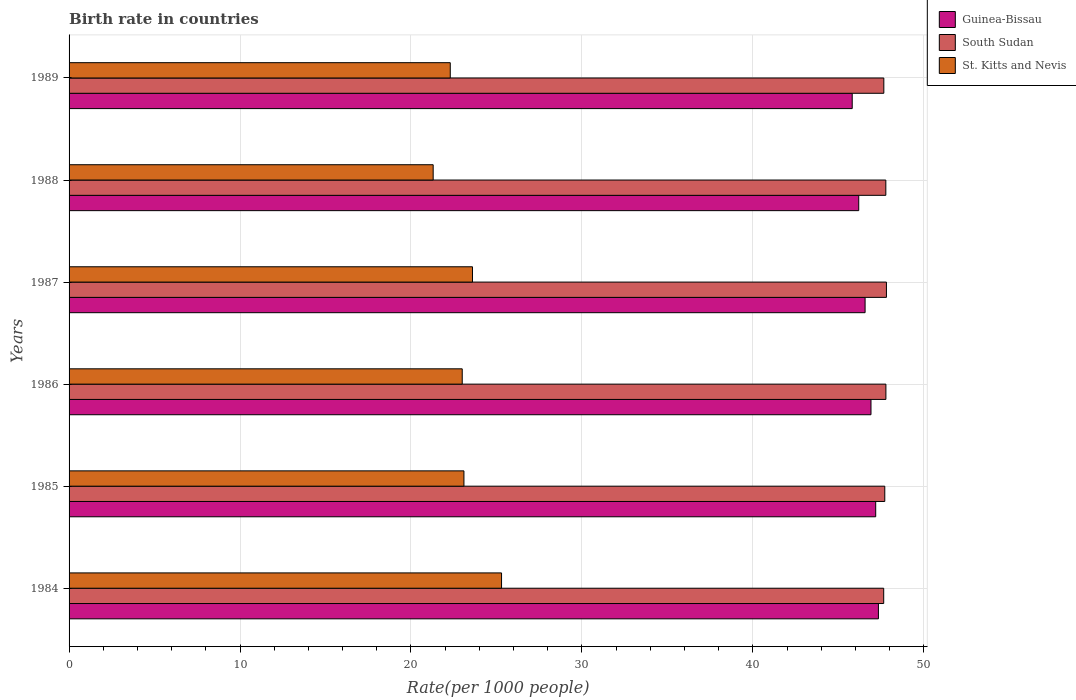How many different coloured bars are there?
Your answer should be compact. 3. How many bars are there on the 3rd tick from the top?
Your answer should be very brief. 3. What is the birth rate in St. Kitts and Nevis in 1988?
Offer a very short reply. 21.3. Across all years, what is the maximum birth rate in South Sudan?
Give a very brief answer. 47.82. Across all years, what is the minimum birth rate in South Sudan?
Offer a very short reply. 47.66. In which year was the birth rate in St. Kitts and Nevis maximum?
Keep it short and to the point. 1984. In which year was the birth rate in St. Kitts and Nevis minimum?
Ensure brevity in your answer.  1988. What is the total birth rate in St. Kitts and Nevis in the graph?
Offer a very short reply. 138.6. What is the difference between the birth rate in St. Kitts and Nevis in 1986 and that in 1989?
Keep it short and to the point. 0.7. What is the difference between the birth rate in Guinea-Bissau in 1987 and the birth rate in South Sudan in 1984?
Keep it short and to the point. -1.09. What is the average birth rate in St. Kitts and Nevis per year?
Ensure brevity in your answer.  23.1. In the year 1989, what is the difference between the birth rate in St. Kitts and Nevis and birth rate in South Sudan?
Keep it short and to the point. -25.36. In how many years, is the birth rate in South Sudan greater than 4 ?
Keep it short and to the point. 6. What is the ratio of the birth rate in St. Kitts and Nevis in 1984 to that in 1987?
Ensure brevity in your answer.  1.07. Is the birth rate in Guinea-Bissau in 1985 less than that in 1986?
Make the answer very short. No. Is the difference between the birth rate in St. Kitts and Nevis in 1984 and 1987 greater than the difference between the birth rate in South Sudan in 1984 and 1987?
Your answer should be very brief. Yes. What is the difference between the highest and the second highest birth rate in South Sudan?
Provide a short and direct response. 0.03. What is the difference between the highest and the lowest birth rate in South Sudan?
Give a very brief answer. 0.16. What does the 1st bar from the top in 1987 represents?
Offer a very short reply. St. Kitts and Nevis. What does the 2nd bar from the bottom in 1984 represents?
Give a very brief answer. South Sudan. Is it the case that in every year, the sum of the birth rate in Guinea-Bissau and birth rate in South Sudan is greater than the birth rate in St. Kitts and Nevis?
Provide a short and direct response. Yes. How many years are there in the graph?
Your answer should be compact. 6. Does the graph contain any zero values?
Provide a succinct answer. No. Does the graph contain grids?
Make the answer very short. Yes. Where does the legend appear in the graph?
Your answer should be very brief. Top right. What is the title of the graph?
Offer a terse response. Birth rate in countries. What is the label or title of the X-axis?
Make the answer very short. Rate(per 1000 people). What is the Rate(per 1000 people) of Guinea-Bissau in 1984?
Your answer should be compact. 47.35. What is the Rate(per 1000 people) of South Sudan in 1984?
Offer a very short reply. 47.66. What is the Rate(per 1000 people) of St. Kitts and Nevis in 1984?
Offer a terse response. 25.3. What is the Rate(per 1000 people) in Guinea-Bissau in 1985?
Ensure brevity in your answer.  47.19. What is the Rate(per 1000 people) in South Sudan in 1985?
Offer a very short reply. 47.72. What is the Rate(per 1000 people) of St. Kitts and Nevis in 1985?
Your response must be concise. 23.1. What is the Rate(per 1000 people) of Guinea-Bissau in 1986?
Give a very brief answer. 46.91. What is the Rate(per 1000 people) of South Sudan in 1986?
Offer a very short reply. 47.78. What is the Rate(per 1000 people) of St. Kitts and Nevis in 1986?
Your response must be concise. 23. What is the Rate(per 1000 people) of Guinea-Bissau in 1987?
Give a very brief answer. 46.57. What is the Rate(per 1000 people) of South Sudan in 1987?
Your answer should be very brief. 47.82. What is the Rate(per 1000 people) of St. Kitts and Nevis in 1987?
Give a very brief answer. 23.6. What is the Rate(per 1000 people) in Guinea-Bissau in 1988?
Provide a short and direct response. 46.2. What is the Rate(per 1000 people) of South Sudan in 1988?
Your answer should be compact. 47.78. What is the Rate(per 1000 people) in St. Kitts and Nevis in 1988?
Your answer should be very brief. 21.3. What is the Rate(per 1000 people) of Guinea-Bissau in 1989?
Your answer should be compact. 45.81. What is the Rate(per 1000 people) in South Sudan in 1989?
Your response must be concise. 47.66. What is the Rate(per 1000 people) of St. Kitts and Nevis in 1989?
Provide a succinct answer. 22.3. Across all years, what is the maximum Rate(per 1000 people) in Guinea-Bissau?
Offer a very short reply. 47.35. Across all years, what is the maximum Rate(per 1000 people) in South Sudan?
Offer a terse response. 47.82. Across all years, what is the maximum Rate(per 1000 people) of St. Kitts and Nevis?
Offer a very short reply. 25.3. Across all years, what is the minimum Rate(per 1000 people) of Guinea-Bissau?
Your answer should be very brief. 45.81. Across all years, what is the minimum Rate(per 1000 people) of South Sudan?
Provide a succinct answer. 47.66. Across all years, what is the minimum Rate(per 1000 people) of St. Kitts and Nevis?
Provide a short and direct response. 21.3. What is the total Rate(per 1000 people) in Guinea-Bissau in the graph?
Keep it short and to the point. 280.02. What is the total Rate(per 1000 people) of South Sudan in the graph?
Your answer should be compact. 286.42. What is the total Rate(per 1000 people) of St. Kitts and Nevis in the graph?
Your response must be concise. 138.6. What is the difference between the Rate(per 1000 people) of Guinea-Bissau in 1984 and that in 1985?
Provide a succinct answer. 0.16. What is the difference between the Rate(per 1000 people) of South Sudan in 1984 and that in 1985?
Make the answer very short. -0.06. What is the difference between the Rate(per 1000 people) of St. Kitts and Nevis in 1984 and that in 1985?
Make the answer very short. 2.2. What is the difference between the Rate(per 1000 people) in Guinea-Bissau in 1984 and that in 1986?
Your answer should be very brief. 0.43. What is the difference between the Rate(per 1000 people) of South Sudan in 1984 and that in 1986?
Ensure brevity in your answer.  -0.13. What is the difference between the Rate(per 1000 people) in Guinea-Bissau in 1984 and that in 1987?
Keep it short and to the point. 0.78. What is the difference between the Rate(per 1000 people) of South Sudan in 1984 and that in 1987?
Give a very brief answer. -0.16. What is the difference between the Rate(per 1000 people) of St. Kitts and Nevis in 1984 and that in 1987?
Make the answer very short. 1.7. What is the difference between the Rate(per 1000 people) in Guinea-Bissau in 1984 and that in 1988?
Give a very brief answer. 1.15. What is the difference between the Rate(per 1000 people) of South Sudan in 1984 and that in 1988?
Give a very brief answer. -0.12. What is the difference between the Rate(per 1000 people) of St. Kitts and Nevis in 1984 and that in 1988?
Your answer should be compact. 4. What is the difference between the Rate(per 1000 people) of Guinea-Bissau in 1984 and that in 1989?
Offer a terse response. 1.53. What is the difference between the Rate(per 1000 people) in South Sudan in 1984 and that in 1989?
Provide a short and direct response. -0.01. What is the difference between the Rate(per 1000 people) in Guinea-Bissau in 1985 and that in 1986?
Your answer should be very brief. 0.28. What is the difference between the Rate(per 1000 people) of South Sudan in 1985 and that in 1986?
Your response must be concise. -0.07. What is the difference between the Rate(per 1000 people) in Guinea-Bissau in 1985 and that in 1987?
Offer a very short reply. 0.62. What is the difference between the Rate(per 1000 people) in South Sudan in 1985 and that in 1987?
Provide a succinct answer. -0.1. What is the difference between the Rate(per 1000 people) in South Sudan in 1985 and that in 1988?
Offer a very short reply. -0.06. What is the difference between the Rate(per 1000 people) of Guinea-Bissau in 1985 and that in 1989?
Offer a terse response. 1.37. What is the difference between the Rate(per 1000 people) in South Sudan in 1985 and that in 1989?
Your response must be concise. 0.06. What is the difference between the Rate(per 1000 people) in St. Kitts and Nevis in 1985 and that in 1989?
Your response must be concise. 0.8. What is the difference between the Rate(per 1000 people) of Guinea-Bissau in 1986 and that in 1987?
Provide a succinct answer. 0.34. What is the difference between the Rate(per 1000 people) of South Sudan in 1986 and that in 1987?
Offer a very short reply. -0.03. What is the difference between the Rate(per 1000 people) of Guinea-Bissau in 1986 and that in 1988?
Your response must be concise. 0.72. What is the difference between the Rate(per 1000 people) in South Sudan in 1986 and that in 1988?
Keep it short and to the point. 0.01. What is the difference between the Rate(per 1000 people) in St. Kitts and Nevis in 1986 and that in 1988?
Your answer should be compact. 1.7. What is the difference between the Rate(per 1000 people) in Guinea-Bissau in 1986 and that in 1989?
Provide a succinct answer. 1.1. What is the difference between the Rate(per 1000 people) in South Sudan in 1986 and that in 1989?
Your answer should be very brief. 0.12. What is the difference between the Rate(per 1000 people) of Guinea-Bissau in 1987 and that in 1988?
Offer a very short reply. 0.37. What is the difference between the Rate(per 1000 people) of South Sudan in 1987 and that in 1988?
Make the answer very short. 0.04. What is the difference between the Rate(per 1000 people) in St. Kitts and Nevis in 1987 and that in 1988?
Give a very brief answer. 2.3. What is the difference between the Rate(per 1000 people) in Guinea-Bissau in 1987 and that in 1989?
Offer a very short reply. 0.75. What is the difference between the Rate(per 1000 people) in South Sudan in 1987 and that in 1989?
Offer a very short reply. 0.15. What is the difference between the Rate(per 1000 people) of Guinea-Bissau in 1988 and that in 1989?
Offer a terse response. 0.38. What is the difference between the Rate(per 1000 people) of South Sudan in 1988 and that in 1989?
Your response must be concise. 0.12. What is the difference between the Rate(per 1000 people) in St. Kitts and Nevis in 1988 and that in 1989?
Your answer should be very brief. -1. What is the difference between the Rate(per 1000 people) in Guinea-Bissau in 1984 and the Rate(per 1000 people) in South Sudan in 1985?
Your answer should be very brief. -0.37. What is the difference between the Rate(per 1000 people) in Guinea-Bissau in 1984 and the Rate(per 1000 people) in St. Kitts and Nevis in 1985?
Offer a terse response. 24.25. What is the difference between the Rate(per 1000 people) of South Sudan in 1984 and the Rate(per 1000 people) of St. Kitts and Nevis in 1985?
Offer a very short reply. 24.56. What is the difference between the Rate(per 1000 people) in Guinea-Bissau in 1984 and the Rate(per 1000 people) in South Sudan in 1986?
Ensure brevity in your answer.  -0.44. What is the difference between the Rate(per 1000 people) of Guinea-Bissau in 1984 and the Rate(per 1000 people) of St. Kitts and Nevis in 1986?
Your answer should be very brief. 24.35. What is the difference between the Rate(per 1000 people) in South Sudan in 1984 and the Rate(per 1000 people) in St. Kitts and Nevis in 1986?
Offer a very short reply. 24.66. What is the difference between the Rate(per 1000 people) of Guinea-Bissau in 1984 and the Rate(per 1000 people) of South Sudan in 1987?
Your answer should be compact. -0.47. What is the difference between the Rate(per 1000 people) in Guinea-Bissau in 1984 and the Rate(per 1000 people) in St. Kitts and Nevis in 1987?
Your response must be concise. 23.75. What is the difference between the Rate(per 1000 people) in South Sudan in 1984 and the Rate(per 1000 people) in St. Kitts and Nevis in 1987?
Your response must be concise. 24.06. What is the difference between the Rate(per 1000 people) of Guinea-Bissau in 1984 and the Rate(per 1000 people) of South Sudan in 1988?
Offer a very short reply. -0.43. What is the difference between the Rate(per 1000 people) in Guinea-Bissau in 1984 and the Rate(per 1000 people) in St. Kitts and Nevis in 1988?
Make the answer very short. 26.05. What is the difference between the Rate(per 1000 people) in South Sudan in 1984 and the Rate(per 1000 people) in St. Kitts and Nevis in 1988?
Offer a terse response. 26.36. What is the difference between the Rate(per 1000 people) in Guinea-Bissau in 1984 and the Rate(per 1000 people) in South Sudan in 1989?
Make the answer very short. -0.32. What is the difference between the Rate(per 1000 people) of Guinea-Bissau in 1984 and the Rate(per 1000 people) of St. Kitts and Nevis in 1989?
Provide a succinct answer. 25.05. What is the difference between the Rate(per 1000 people) in South Sudan in 1984 and the Rate(per 1000 people) in St. Kitts and Nevis in 1989?
Keep it short and to the point. 25.36. What is the difference between the Rate(per 1000 people) of Guinea-Bissau in 1985 and the Rate(per 1000 people) of South Sudan in 1986?
Your response must be concise. -0.6. What is the difference between the Rate(per 1000 people) of Guinea-Bissau in 1985 and the Rate(per 1000 people) of St. Kitts and Nevis in 1986?
Provide a short and direct response. 24.19. What is the difference between the Rate(per 1000 people) in South Sudan in 1985 and the Rate(per 1000 people) in St. Kitts and Nevis in 1986?
Your answer should be compact. 24.72. What is the difference between the Rate(per 1000 people) in Guinea-Bissau in 1985 and the Rate(per 1000 people) in South Sudan in 1987?
Make the answer very short. -0.63. What is the difference between the Rate(per 1000 people) of Guinea-Bissau in 1985 and the Rate(per 1000 people) of St. Kitts and Nevis in 1987?
Make the answer very short. 23.59. What is the difference between the Rate(per 1000 people) in South Sudan in 1985 and the Rate(per 1000 people) in St. Kitts and Nevis in 1987?
Provide a short and direct response. 24.12. What is the difference between the Rate(per 1000 people) of Guinea-Bissau in 1985 and the Rate(per 1000 people) of South Sudan in 1988?
Ensure brevity in your answer.  -0.59. What is the difference between the Rate(per 1000 people) of Guinea-Bissau in 1985 and the Rate(per 1000 people) of St. Kitts and Nevis in 1988?
Make the answer very short. 25.89. What is the difference between the Rate(per 1000 people) of South Sudan in 1985 and the Rate(per 1000 people) of St. Kitts and Nevis in 1988?
Your answer should be compact. 26.42. What is the difference between the Rate(per 1000 people) in Guinea-Bissau in 1985 and the Rate(per 1000 people) in South Sudan in 1989?
Offer a very short reply. -0.47. What is the difference between the Rate(per 1000 people) in Guinea-Bissau in 1985 and the Rate(per 1000 people) in St. Kitts and Nevis in 1989?
Provide a succinct answer. 24.89. What is the difference between the Rate(per 1000 people) in South Sudan in 1985 and the Rate(per 1000 people) in St. Kitts and Nevis in 1989?
Your answer should be very brief. 25.42. What is the difference between the Rate(per 1000 people) in Guinea-Bissau in 1986 and the Rate(per 1000 people) in South Sudan in 1987?
Provide a short and direct response. -0.9. What is the difference between the Rate(per 1000 people) in Guinea-Bissau in 1986 and the Rate(per 1000 people) in St. Kitts and Nevis in 1987?
Give a very brief answer. 23.31. What is the difference between the Rate(per 1000 people) in South Sudan in 1986 and the Rate(per 1000 people) in St. Kitts and Nevis in 1987?
Give a very brief answer. 24.18. What is the difference between the Rate(per 1000 people) in Guinea-Bissau in 1986 and the Rate(per 1000 people) in South Sudan in 1988?
Give a very brief answer. -0.87. What is the difference between the Rate(per 1000 people) in Guinea-Bissau in 1986 and the Rate(per 1000 people) in St. Kitts and Nevis in 1988?
Offer a terse response. 25.61. What is the difference between the Rate(per 1000 people) in South Sudan in 1986 and the Rate(per 1000 people) in St. Kitts and Nevis in 1988?
Your answer should be very brief. 26.48. What is the difference between the Rate(per 1000 people) of Guinea-Bissau in 1986 and the Rate(per 1000 people) of South Sudan in 1989?
Offer a terse response. -0.75. What is the difference between the Rate(per 1000 people) of Guinea-Bissau in 1986 and the Rate(per 1000 people) of St. Kitts and Nevis in 1989?
Ensure brevity in your answer.  24.61. What is the difference between the Rate(per 1000 people) in South Sudan in 1986 and the Rate(per 1000 people) in St. Kitts and Nevis in 1989?
Ensure brevity in your answer.  25.48. What is the difference between the Rate(per 1000 people) of Guinea-Bissau in 1987 and the Rate(per 1000 people) of South Sudan in 1988?
Provide a short and direct response. -1.21. What is the difference between the Rate(per 1000 people) in Guinea-Bissau in 1987 and the Rate(per 1000 people) in St. Kitts and Nevis in 1988?
Give a very brief answer. 25.27. What is the difference between the Rate(per 1000 people) in South Sudan in 1987 and the Rate(per 1000 people) in St. Kitts and Nevis in 1988?
Keep it short and to the point. 26.52. What is the difference between the Rate(per 1000 people) in Guinea-Bissau in 1987 and the Rate(per 1000 people) in South Sudan in 1989?
Ensure brevity in your answer.  -1.1. What is the difference between the Rate(per 1000 people) in Guinea-Bissau in 1987 and the Rate(per 1000 people) in St. Kitts and Nevis in 1989?
Your answer should be compact. 24.27. What is the difference between the Rate(per 1000 people) in South Sudan in 1987 and the Rate(per 1000 people) in St. Kitts and Nevis in 1989?
Give a very brief answer. 25.52. What is the difference between the Rate(per 1000 people) of Guinea-Bissau in 1988 and the Rate(per 1000 people) of South Sudan in 1989?
Offer a terse response. -1.47. What is the difference between the Rate(per 1000 people) of Guinea-Bissau in 1988 and the Rate(per 1000 people) of St. Kitts and Nevis in 1989?
Your response must be concise. 23.89. What is the difference between the Rate(per 1000 people) of South Sudan in 1988 and the Rate(per 1000 people) of St. Kitts and Nevis in 1989?
Provide a succinct answer. 25.48. What is the average Rate(per 1000 people) of Guinea-Bissau per year?
Provide a succinct answer. 46.67. What is the average Rate(per 1000 people) of South Sudan per year?
Provide a succinct answer. 47.74. What is the average Rate(per 1000 people) of St. Kitts and Nevis per year?
Keep it short and to the point. 23.1. In the year 1984, what is the difference between the Rate(per 1000 people) of Guinea-Bissau and Rate(per 1000 people) of South Sudan?
Make the answer very short. -0.31. In the year 1984, what is the difference between the Rate(per 1000 people) in Guinea-Bissau and Rate(per 1000 people) in St. Kitts and Nevis?
Your response must be concise. 22.05. In the year 1984, what is the difference between the Rate(per 1000 people) in South Sudan and Rate(per 1000 people) in St. Kitts and Nevis?
Offer a very short reply. 22.36. In the year 1985, what is the difference between the Rate(per 1000 people) of Guinea-Bissau and Rate(per 1000 people) of South Sudan?
Provide a short and direct response. -0.53. In the year 1985, what is the difference between the Rate(per 1000 people) in Guinea-Bissau and Rate(per 1000 people) in St. Kitts and Nevis?
Give a very brief answer. 24.09. In the year 1985, what is the difference between the Rate(per 1000 people) of South Sudan and Rate(per 1000 people) of St. Kitts and Nevis?
Offer a terse response. 24.62. In the year 1986, what is the difference between the Rate(per 1000 people) of Guinea-Bissau and Rate(per 1000 people) of South Sudan?
Ensure brevity in your answer.  -0.87. In the year 1986, what is the difference between the Rate(per 1000 people) in Guinea-Bissau and Rate(per 1000 people) in St. Kitts and Nevis?
Keep it short and to the point. 23.91. In the year 1986, what is the difference between the Rate(per 1000 people) in South Sudan and Rate(per 1000 people) in St. Kitts and Nevis?
Provide a short and direct response. 24.79. In the year 1987, what is the difference between the Rate(per 1000 people) of Guinea-Bissau and Rate(per 1000 people) of South Sudan?
Provide a short and direct response. -1.25. In the year 1987, what is the difference between the Rate(per 1000 people) in Guinea-Bissau and Rate(per 1000 people) in St. Kitts and Nevis?
Offer a very short reply. 22.97. In the year 1987, what is the difference between the Rate(per 1000 people) in South Sudan and Rate(per 1000 people) in St. Kitts and Nevis?
Give a very brief answer. 24.22. In the year 1988, what is the difference between the Rate(per 1000 people) of Guinea-Bissau and Rate(per 1000 people) of South Sudan?
Offer a terse response. -1.58. In the year 1988, what is the difference between the Rate(per 1000 people) of Guinea-Bissau and Rate(per 1000 people) of St. Kitts and Nevis?
Provide a short and direct response. 24.89. In the year 1988, what is the difference between the Rate(per 1000 people) in South Sudan and Rate(per 1000 people) in St. Kitts and Nevis?
Your answer should be compact. 26.48. In the year 1989, what is the difference between the Rate(per 1000 people) of Guinea-Bissau and Rate(per 1000 people) of South Sudan?
Make the answer very short. -1.85. In the year 1989, what is the difference between the Rate(per 1000 people) of Guinea-Bissau and Rate(per 1000 people) of St. Kitts and Nevis?
Ensure brevity in your answer.  23.51. In the year 1989, what is the difference between the Rate(per 1000 people) of South Sudan and Rate(per 1000 people) of St. Kitts and Nevis?
Your answer should be very brief. 25.36. What is the ratio of the Rate(per 1000 people) in Guinea-Bissau in 1984 to that in 1985?
Provide a succinct answer. 1. What is the ratio of the Rate(per 1000 people) of South Sudan in 1984 to that in 1985?
Provide a short and direct response. 1. What is the ratio of the Rate(per 1000 people) of St. Kitts and Nevis in 1984 to that in 1985?
Make the answer very short. 1.1. What is the ratio of the Rate(per 1000 people) of Guinea-Bissau in 1984 to that in 1986?
Provide a succinct answer. 1.01. What is the ratio of the Rate(per 1000 people) in South Sudan in 1984 to that in 1986?
Give a very brief answer. 1. What is the ratio of the Rate(per 1000 people) of St. Kitts and Nevis in 1984 to that in 1986?
Offer a terse response. 1.1. What is the ratio of the Rate(per 1000 people) in Guinea-Bissau in 1984 to that in 1987?
Offer a terse response. 1.02. What is the ratio of the Rate(per 1000 people) in South Sudan in 1984 to that in 1987?
Your response must be concise. 1. What is the ratio of the Rate(per 1000 people) of St. Kitts and Nevis in 1984 to that in 1987?
Ensure brevity in your answer.  1.07. What is the ratio of the Rate(per 1000 people) in Guinea-Bissau in 1984 to that in 1988?
Provide a short and direct response. 1.02. What is the ratio of the Rate(per 1000 people) in St. Kitts and Nevis in 1984 to that in 1988?
Your answer should be very brief. 1.19. What is the ratio of the Rate(per 1000 people) of Guinea-Bissau in 1984 to that in 1989?
Offer a terse response. 1.03. What is the ratio of the Rate(per 1000 people) of South Sudan in 1984 to that in 1989?
Make the answer very short. 1. What is the ratio of the Rate(per 1000 people) in St. Kitts and Nevis in 1984 to that in 1989?
Offer a terse response. 1.13. What is the ratio of the Rate(per 1000 people) of Guinea-Bissau in 1985 to that in 1986?
Provide a succinct answer. 1.01. What is the ratio of the Rate(per 1000 people) of St. Kitts and Nevis in 1985 to that in 1986?
Offer a very short reply. 1. What is the ratio of the Rate(per 1000 people) of Guinea-Bissau in 1985 to that in 1987?
Keep it short and to the point. 1.01. What is the ratio of the Rate(per 1000 people) of St. Kitts and Nevis in 1985 to that in 1987?
Ensure brevity in your answer.  0.98. What is the ratio of the Rate(per 1000 people) of Guinea-Bissau in 1985 to that in 1988?
Ensure brevity in your answer.  1.02. What is the ratio of the Rate(per 1000 people) of South Sudan in 1985 to that in 1988?
Keep it short and to the point. 1. What is the ratio of the Rate(per 1000 people) in St. Kitts and Nevis in 1985 to that in 1988?
Your response must be concise. 1.08. What is the ratio of the Rate(per 1000 people) in South Sudan in 1985 to that in 1989?
Your answer should be compact. 1. What is the ratio of the Rate(per 1000 people) in St. Kitts and Nevis in 1985 to that in 1989?
Your response must be concise. 1.04. What is the ratio of the Rate(per 1000 people) in Guinea-Bissau in 1986 to that in 1987?
Your answer should be compact. 1.01. What is the ratio of the Rate(per 1000 people) in St. Kitts and Nevis in 1986 to that in 1987?
Offer a very short reply. 0.97. What is the ratio of the Rate(per 1000 people) of Guinea-Bissau in 1986 to that in 1988?
Offer a very short reply. 1.02. What is the ratio of the Rate(per 1000 people) of South Sudan in 1986 to that in 1988?
Make the answer very short. 1. What is the ratio of the Rate(per 1000 people) of St. Kitts and Nevis in 1986 to that in 1988?
Provide a succinct answer. 1.08. What is the ratio of the Rate(per 1000 people) in South Sudan in 1986 to that in 1989?
Offer a very short reply. 1. What is the ratio of the Rate(per 1000 people) of St. Kitts and Nevis in 1986 to that in 1989?
Your answer should be compact. 1.03. What is the ratio of the Rate(per 1000 people) in St. Kitts and Nevis in 1987 to that in 1988?
Give a very brief answer. 1.11. What is the ratio of the Rate(per 1000 people) in Guinea-Bissau in 1987 to that in 1989?
Provide a short and direct response. 1.02. What is the ratio of the Rate(per 1000 people) of South Sudan in 1987 to that in 1989?
Offer a very short reply. 1. What is the ratio of the Rate(per 1000 people) in St. Kitts and Nevis in 1987 to that in 1989?
Provide a short and direct response. 1.06. What is the ratio of the Rate(per 1000 people) in Guinea-Bissau in 1988 to that in 1989?
Your answer should be very brief. 1.01. What is the ratio of the Rate(per 1000 people) in St. Kitts and Nevis in 1988 to that in 1989?
Your response must be concise. 0.96. What is the difference between the highest and the second highest Rate(per 1000 people) of Guinea-Bissau?
Offer a very short reply. 0.16. What is the difference between the highest and the second highest Rate(per 1000 people) of South Sudan?
Offer a terse response. 0.03. What is the difference between the highest and the second highest Rate(per 1000 people) of St. Kitts and Nevis?
Your response must be concise. 1.7. What is the difference between the highest and the lowest Rate(per 1000 people) of Guinea-Bissau?
Provide a short and direct response. 1.53. What is the difference between the highest and the lowest Rate(per 1000 people) in South Sudan?
Offer a terse response. 0.16. What is the difference between the highest and the lowest Rate(per 1000 people) of St. Kitts and Nevis?
Ensure brevity in your answer.  4. 